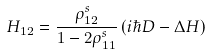<formula> <loc_0><loc_0><loc_500><loc_500>H _ { 1 2 } = \frac { \rho ^ { s } _ { 1 2 } } { 1 - 2 \rho ^ { s } _ { 1 1 } } \left ( i \hbar { D } - \Delta H \right )</formula> 